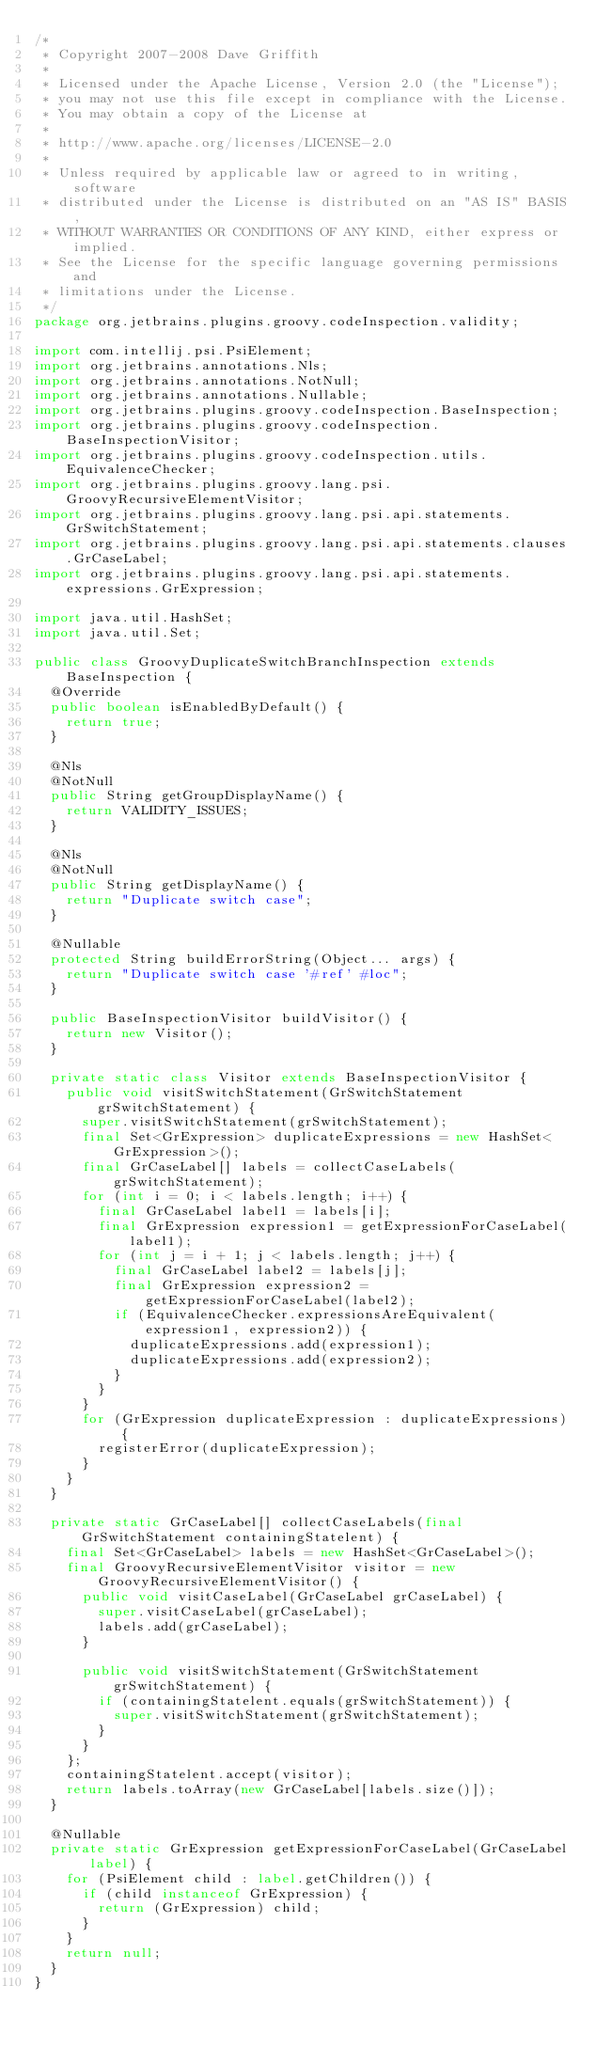<code> <loc_0><loc_0><loc_500><loc_500><_Java_>/*
 * Copyright 2007-2008 Dave Griffith
 *
 * Licensed under the Apache License, Version 2.0 (the "License");
 * you may not use this file except in compliance with the License.
 * You may obtain a copy of the License at
 *
 * http://www.apache.org/licenses/LICENSE-2.0
 *
 * Unless required by applicable law or agreed to in writing, software
 * distributed under the License is distributed on an "AS IS" BASIS,
 * WITHOUT WARRANTIES OR CONDITIONS OF ANY KIND, either express or implied.
 * See the License for the specific language governing permissions and
 * limitations under the License.
 */
package org.jetbrains.plugins.groovy.codeInspection.validity;

import com.intellij.psi.PsiElement;
import org.jetbrains.annotations.Nls;
import org.jetbrains.annotations.NotNull;
import org.jetbrains.annotations.Nullable;
import org.jetbrains.plugins.groovy.codeInspection.BaseInspection;
import org.jetbrains.plugins.groovy.codeInspection.BaseInspectionVisitor;
import org.jetbrains.plugins.groovy.codeInspection.utils.EquivalenceChecker;
import org.jetbrains.plugins.groovy.lang.psi.GroovyRecursiveElementVisitor;
import org.jetbrains.plugins.groovy.lang.psi.api.statements.GrSwitchStatement;
import org.jetbrains.plugins.groovy.lang.psi.api.statements.clauses.GrCaseLabel;
import org.jetbrains.plugins.groovy.lang.psi.api.statements.expressions.GrExpression;

import java.util.HashSet;
import java.util.Set;

public class GroovyDuplicateSwitchBranchInspection extends BaseInspection {
  @Override
  public boolean isEnabledByDefault() {
    return true;
  }

  @Nls
  @NotNull
  public String getGroupDisplayName() {
    return VALIDITY_ISSUES;
  }

  @Nls
  @NotNull
  public String getDisplayName() {
    return "Duplicate switch case";
  }

  @Nullable
  protected String buildErrorString(Object... args) {
    return "Duplicate switch case '#ref' #loc";
  }

  public BaseInspectionVisitor buildVisitor() {
    return new Visitor();
  }

  private static class Visitor extends BaseInspectionVisitor {
    public void visitSwitchStatement(GrSwitchStatement grSwitchStatement) {
      super.visitSwitchStatement(grSwitchStatement);
      final Set<GrExpression> duplicateExpressions = new HashSet<GrExpression>();
      final GrCaseLabel[] labels = collectCaseLabels(grSwitchStatement);
      for (int i = 0; i < labels.length; i++) {
        final GrCaseLabel label1 = labels[i];
        final GrExpression expression1 = getExpressionForCaseLabel(label1);
        for (int j = i + 1; j < labels.length; j++) {
          final GrCaseLabel label2 = labels[j];
          final GrExpression expression2 = getExpressionForCaseLabel(label2);
          if (EquivalenceChecker.expressionsAreEquivalent(expression1, expression2)) {
            duplicateExpressions.add(expression1);
            duplicateExpressions.add(expression2);
          }
        }
      }
      for (GrExpression duplicateExpression : duplicateExpressions) {
        registerError(duplicateExpression);
      }
    }
  }

  private static GrCaseLabel[] collectCaseLabels(final GrSwitchStatement containingStatelent) {
    final Set<GrCaseLabel> labels = new HashSet<GrCaseLabel>();
    final GroovyRecursiveElementVisitor visitor = new GroovyRecursiveElementVisitor() {
      public void visitCaseLabel(GrCaseLabel grCaseLabel) {
        super.visitCaseLabel(grCaseLabel);
        labels.add(grCaseLabel);
      }

      public void visitSwitchStatement(GrSwitchStatement grSwitchStatement) {
        if (containingStatelent.equals(grSwitchStatement)) {
          super.visitSwitchStatement(grSwitchStatement);
        }
      }
    };
    containingStatelent.accept(visitor);
    return labels.toArray(new GrCaseLabel[labels.size()]);
  }

  @Nullable
  private static GrExpression getExpressionForCaseLabel(GrCaseLabel label) {
    for (PsiElement child : label.getChildren()) {
      if (child instanceof GrExpression) {
        return (GrExpression) child;
      }
    }
    return null;
  }
}</code> 